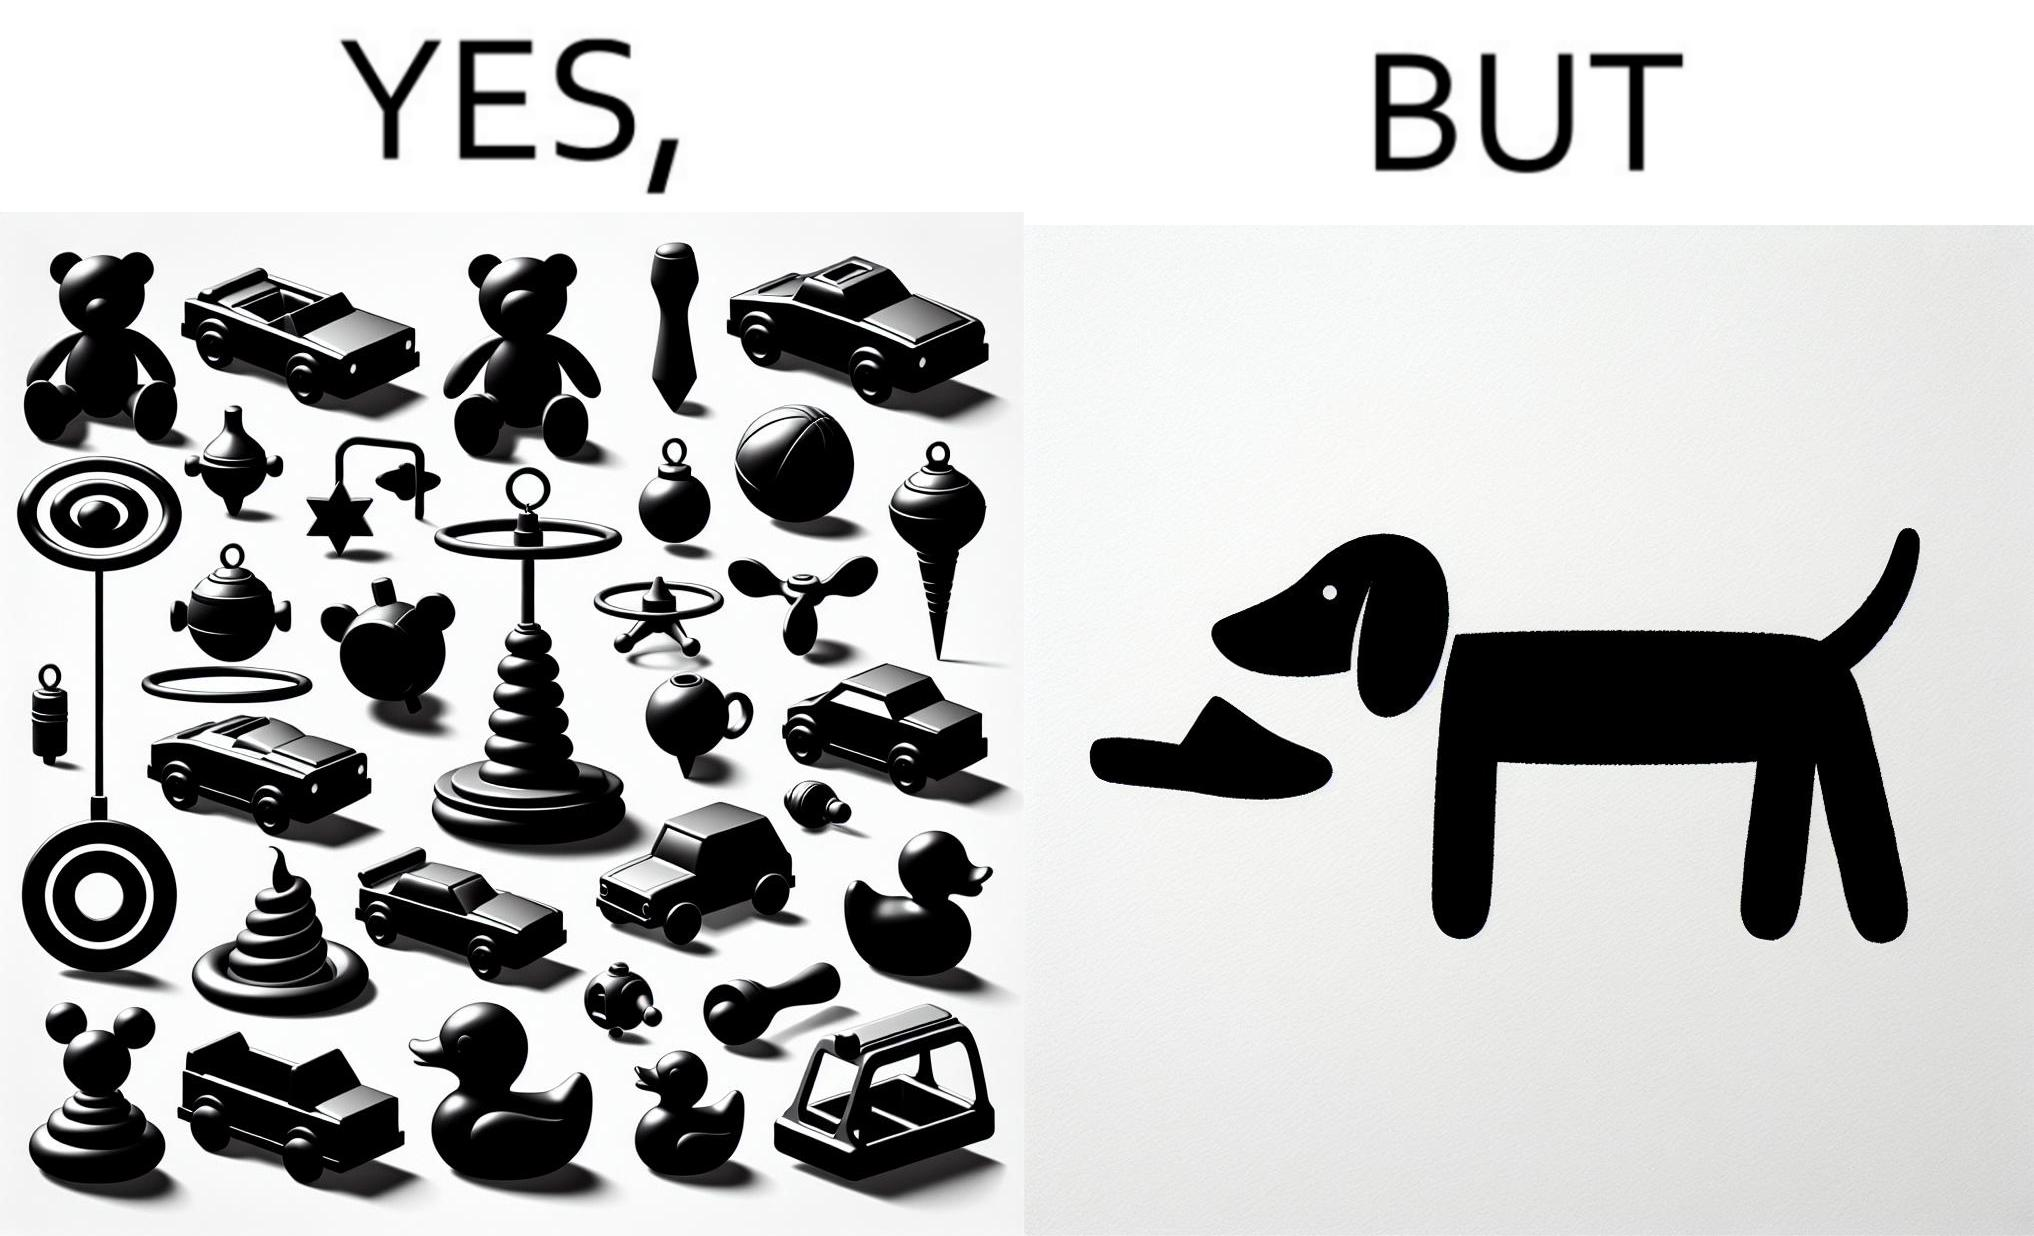What is the satirical meaning behind this image? the irony is that dog owners buy loads of toys for their dog but the dog's favourite toy is the owner's slippers 